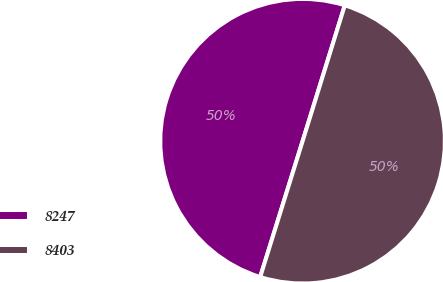Convert chart to OTSL. <chart><loc_0><loc_0><loc_500><loc_500><pie_chart><fcel>8247<fcel>8403<nl><fcel>49.98%<fcel>50.02%<nl></chart> 